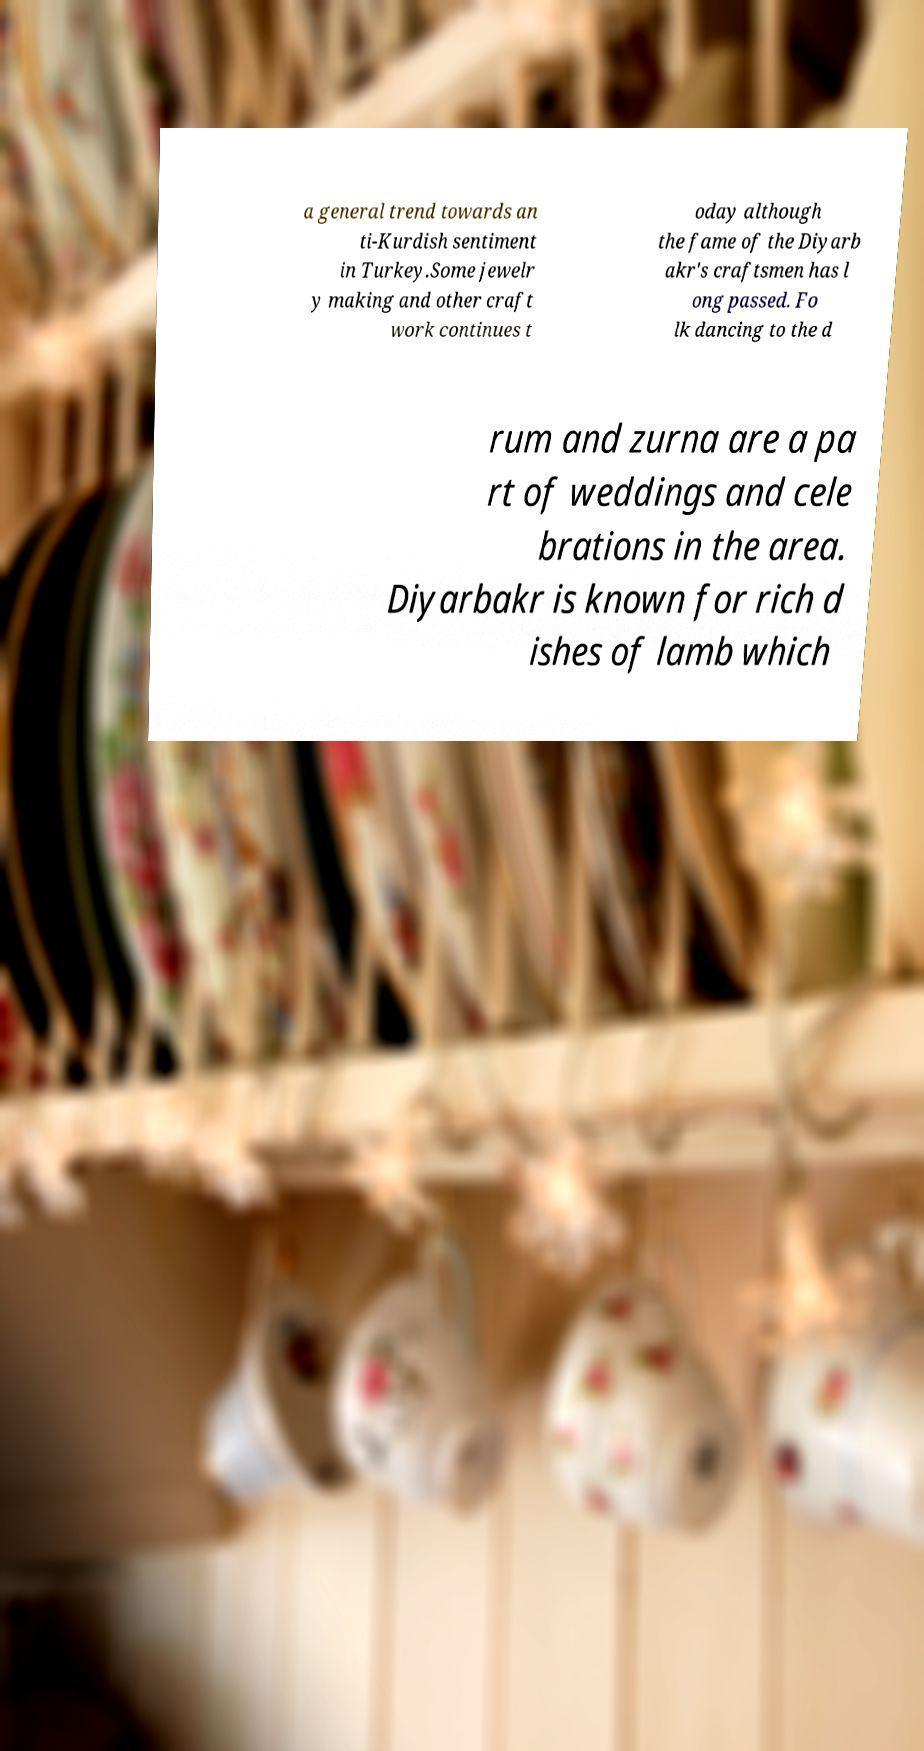Could you assist in decoding the text presented in this image and type it out clearly? a general trend towards an ti-Kurdish sentiment in Turkey.Some jewelr y making and other craft work continues t oday although the fame of the Diyarb akr's craftsmen has l ong passed. Fo lk dancing to the d rum and zurna are a pa rt of weddings and cele brations in the area. Diyarbakr is known for rich d ishes of lamb which 